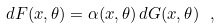<formula> <loc_0><loc_0><loc_500><loc_500>d F ( x , \theta ) = \alpha ( x , \theta ) \, d G ( x , \theta ) \ ,</formula> 